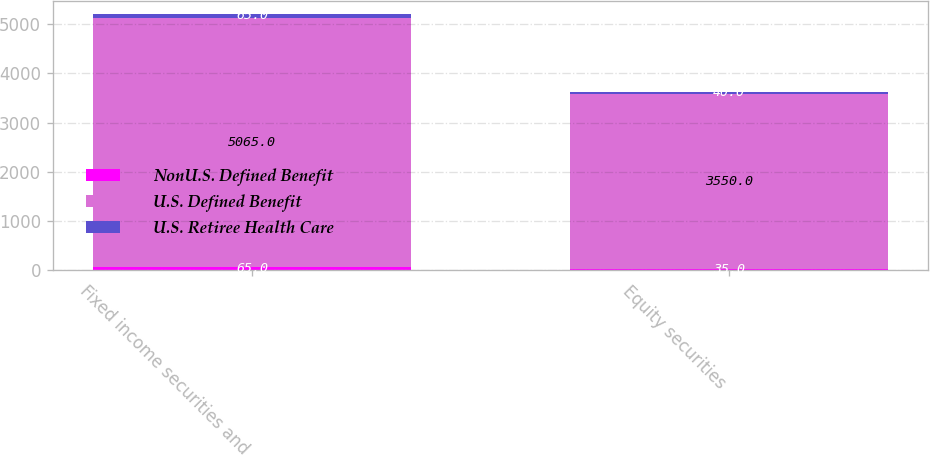Convert chart. <chart><loc_0><loc_0><loc_500><loc_500><stacked_bar_chart><ecel><fcel>Fixed income securities and<fcel>Equity securities<nl><fcel>NonU.S. Defined Benefit<fcel>65<fcel>35<nl><fcel>U.S. Defined Benefit<fcel>5065<fcel>3550<nl><fcel>U.S. Retiree Health Care<fcel>65<fcel>40<nl></chart> 